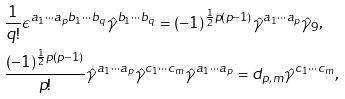Convert formula to latex. <formula><loc_0><loc_0><loc_500><loc_500>& \frac { 1 } { q ! } \epsilon ^ { a _ { 1 } \cdots a _ { p } b _ { 1 } \cdots b _ { q } } \hat { \gamma } ^ { b _ { 1 } \cdots b _ { q } } = ( - 1 ) ^ { \frac { 1 } { 2 } p ( p - 1 ) } \hat { \gamma } ^ { a _ { 1 } \cdots a _ { p } } \hat { \gamma } _ { 9 } , \\ & \frac { ( - 1 ) ^ { \frac { 1 } { 2 } p ( p - 1 ) } } { p ! } \hat { \gamma } ^ { a _ { 1 } \cdots a _ { p } } \hat { \gamma } ^ { c _ { 1 } \cdots c _ { m } } \hat { \gamma } ^ { a _ { 1 } \cdots a _ { p } } = d _ { p , m } \hat { \gamma } ^ { c _ { 1 } \cdots c _ { m } } ,</formula> 